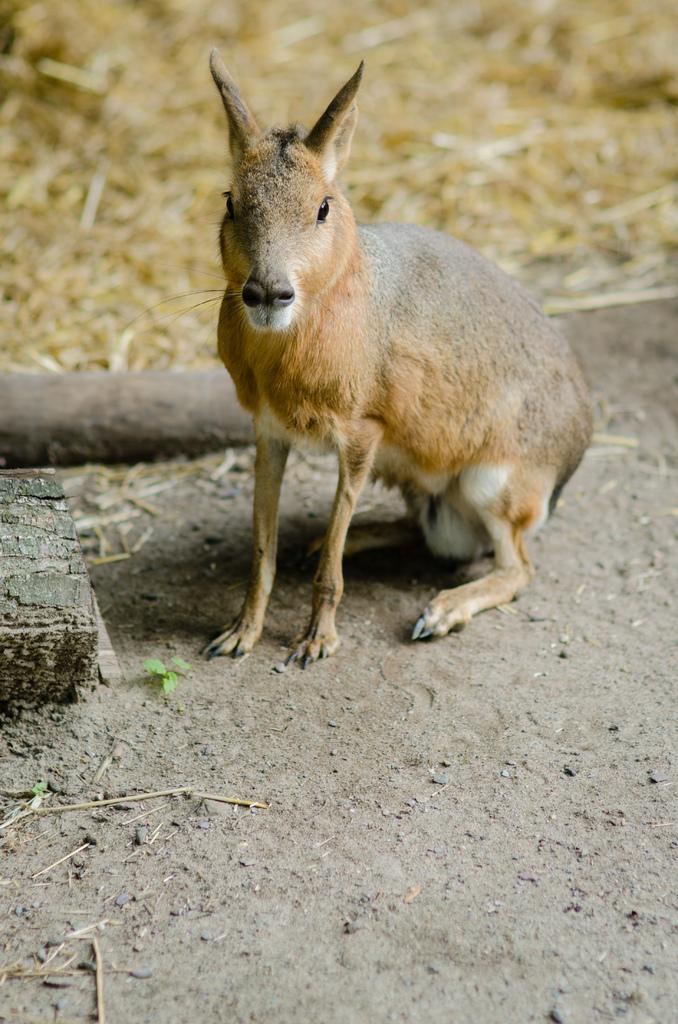What type of animal is in the image? There is a kangaroo in the image. What can be seen at the bottom of the image? There is a ground visible at the bottom of the image. How many kites can be seen in the image? There are no kites present in the image. What type of spots can be seen on the kangaroo in the image? The image does not show any spots on the kangaroo. Is there an army visible in the image? There is no army present in the image. 